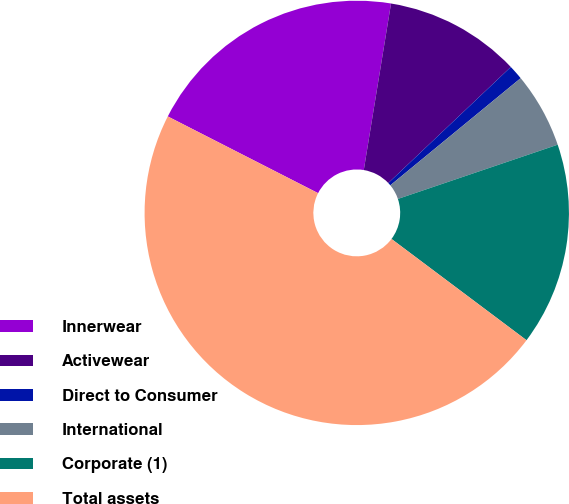Convert chart to OTSL. <chart><loc_0><loc_0><loc_500><loc_500><pie_chart><fcel>Innerwear<fcel>Activewear<fcel>Direct to Consumer<fcel>International<fcel>Corporate (1)<fcel>Total assets<nl><fcel>20.07%<fcel>10.35%<fcel>1.12%<fcel>5.74%<fcel>15.45%<fcel>47.27%<nl></chart> 